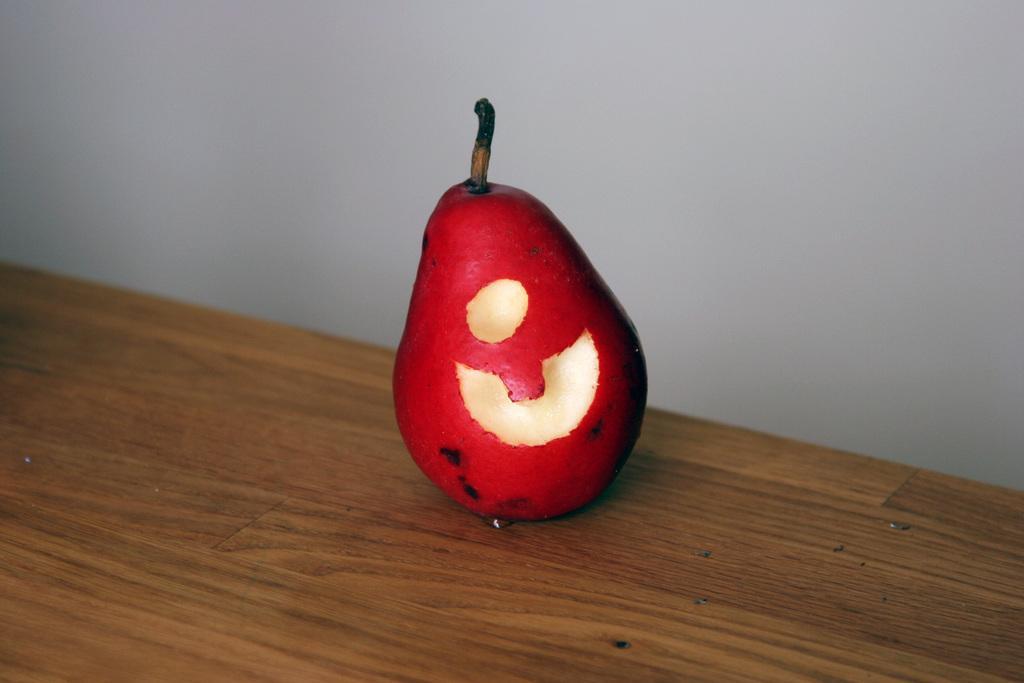Can you describe this image briefly? In the picture there is a pear fruit kept on a wooden surface, behind the fruit there is a wall. 